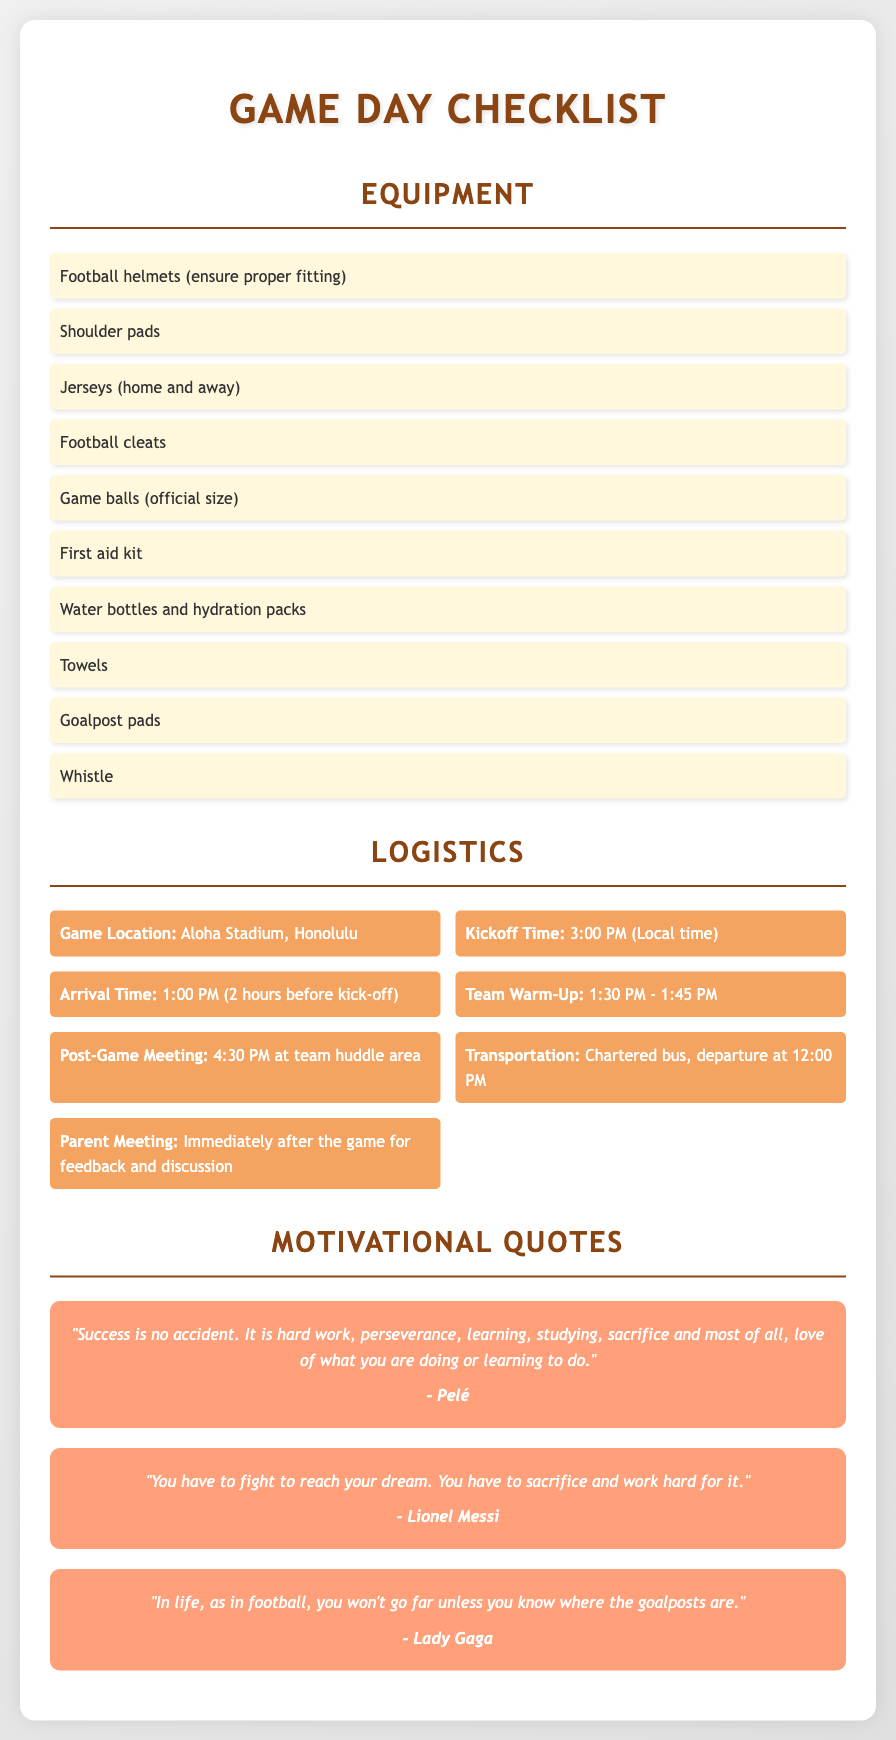What is the game location? The document lists Aloha Stadium, Honolulu as the location for the game.
Answer: Aloha Stadium, Honolulu What time does the game kick off? According to the document, the kickoff time is specified as 3:00 PM.
Answer: 3:00 PM What is the recommended arrival time for the team? The document states that the recommended arrival time is 1:00 PM, two hours before kickoff.
Answer: 1:00 PM Which item is included in the list of equipment? The checklist specifies several items, including football helmets, which are essential equipment for the game.
Answer: Football helmets How long is the team warm-up scheduled for? The document indicates that the team warm-up is scheduled to occur from 1:30 PM to 1:45 PM.
Answer: 15 minutes Who is quoted saying "Success is no accident"? The quote in the document attributes the phrase "Success is no accident" to Pelé.
Answer: Pelé When is the parent meeting scheduled? The document specifies that the parent meeting will occur immediately after the game for feedback and discussion.
Answer: Immediately after the game What transportation method is mentioned for the team? The document mentions that a chartered bus will be used for the team's transportation to the game.
Answer: Chartered bus What time does the team depart for the game? According to the logistics section, the team is set to depart at 12:00 PM.
Answer: 12:00 PM 